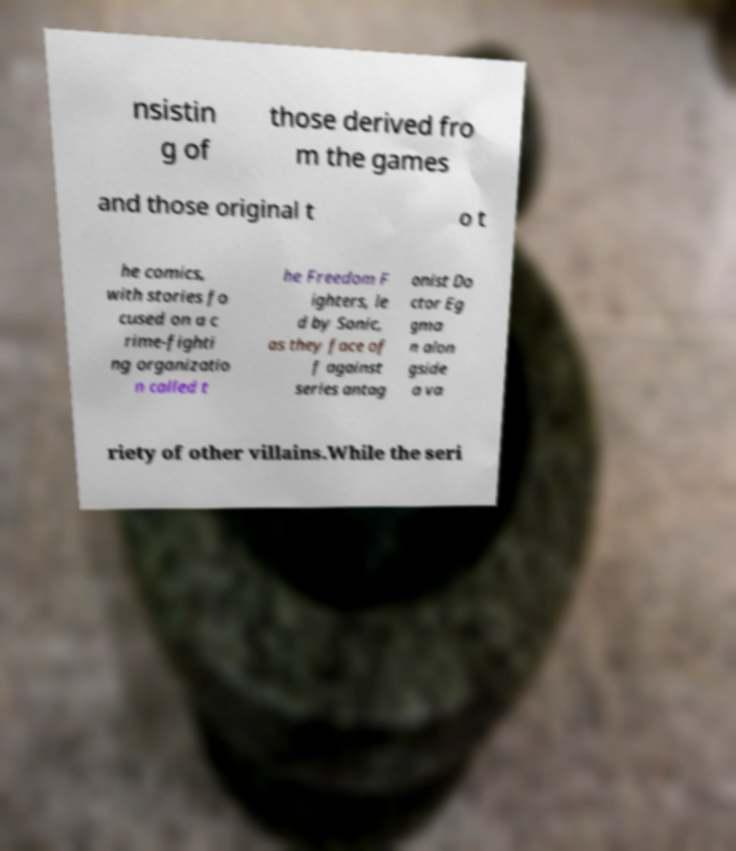There's text embedded in this image that I need extracted. Can you transcribe it verbatim? nsistin g of those derived fro m the games and those original t o t he comics, with stories fo cused on a c rime-fighti ng organizatio n called t he Freedom F ighters, le d by Sonic, as they face of f against series antag onist Do ctor Eg gma n alon gside a va riety of other villains.While the seri 